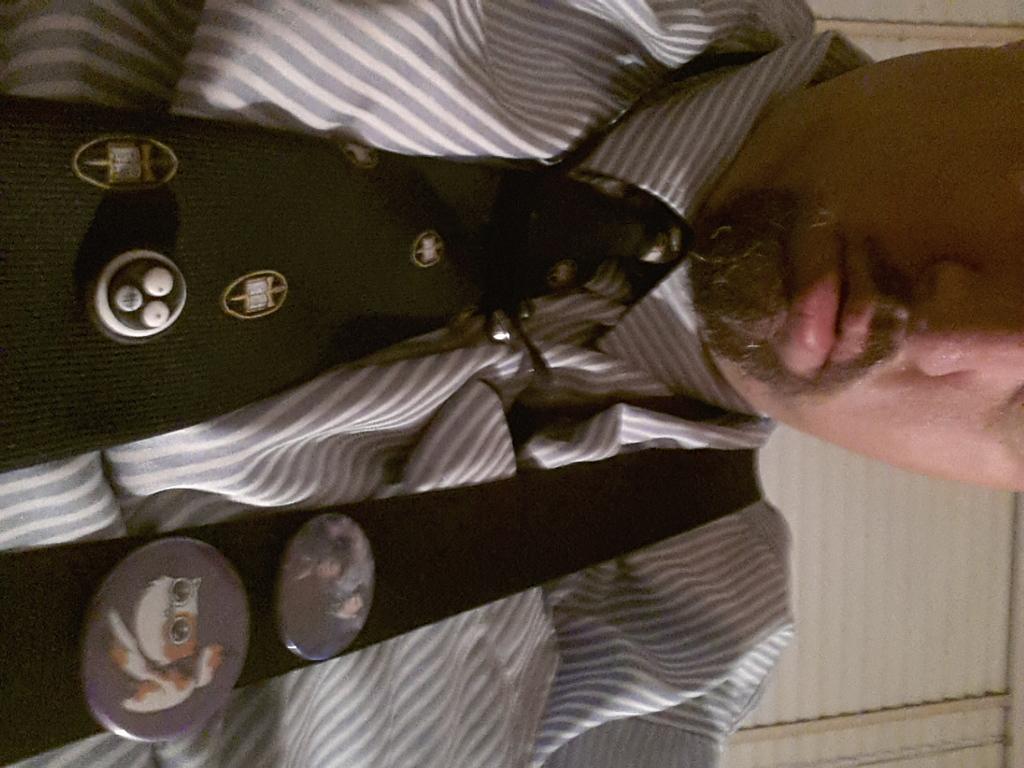How would you summarize this image in a sentence or two? In this image we can see a man. 